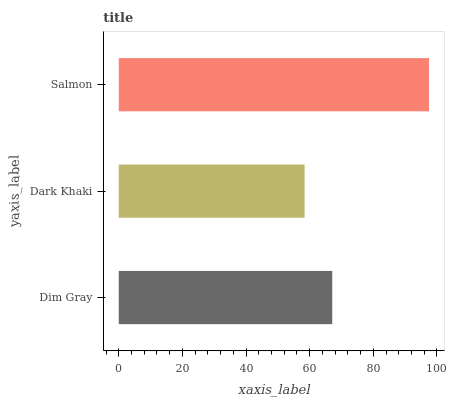Is Dark Khaki the minimum?
Answer yes or no. Yes. Is Salmon the maximum?
Answer yes or no. Yes. Is Salmon the minimum?
Answer yes or no. No. Is Dark Khaki the maximum?
Answer yes or no. No. Is Salmon greater than Dark Khaki?
Answer yes or no. Yes. Is Dark Khaki less than Salmon?
Answer yes or no. Yes. Is Dark Khaki greater than Salmon?
Answer yes or no. No. Is Salmon less than Dark Khaki?
Answer yes or no. No. Is Dim Gray the high median?
Answer yes or no. Yes. Is Dim Gray the low median?
Answer yes or no. Yes. Is Dark Khaki the high median?
Answer yes or no. No. Is Salmon the low median?
Answer yes or no. No. 